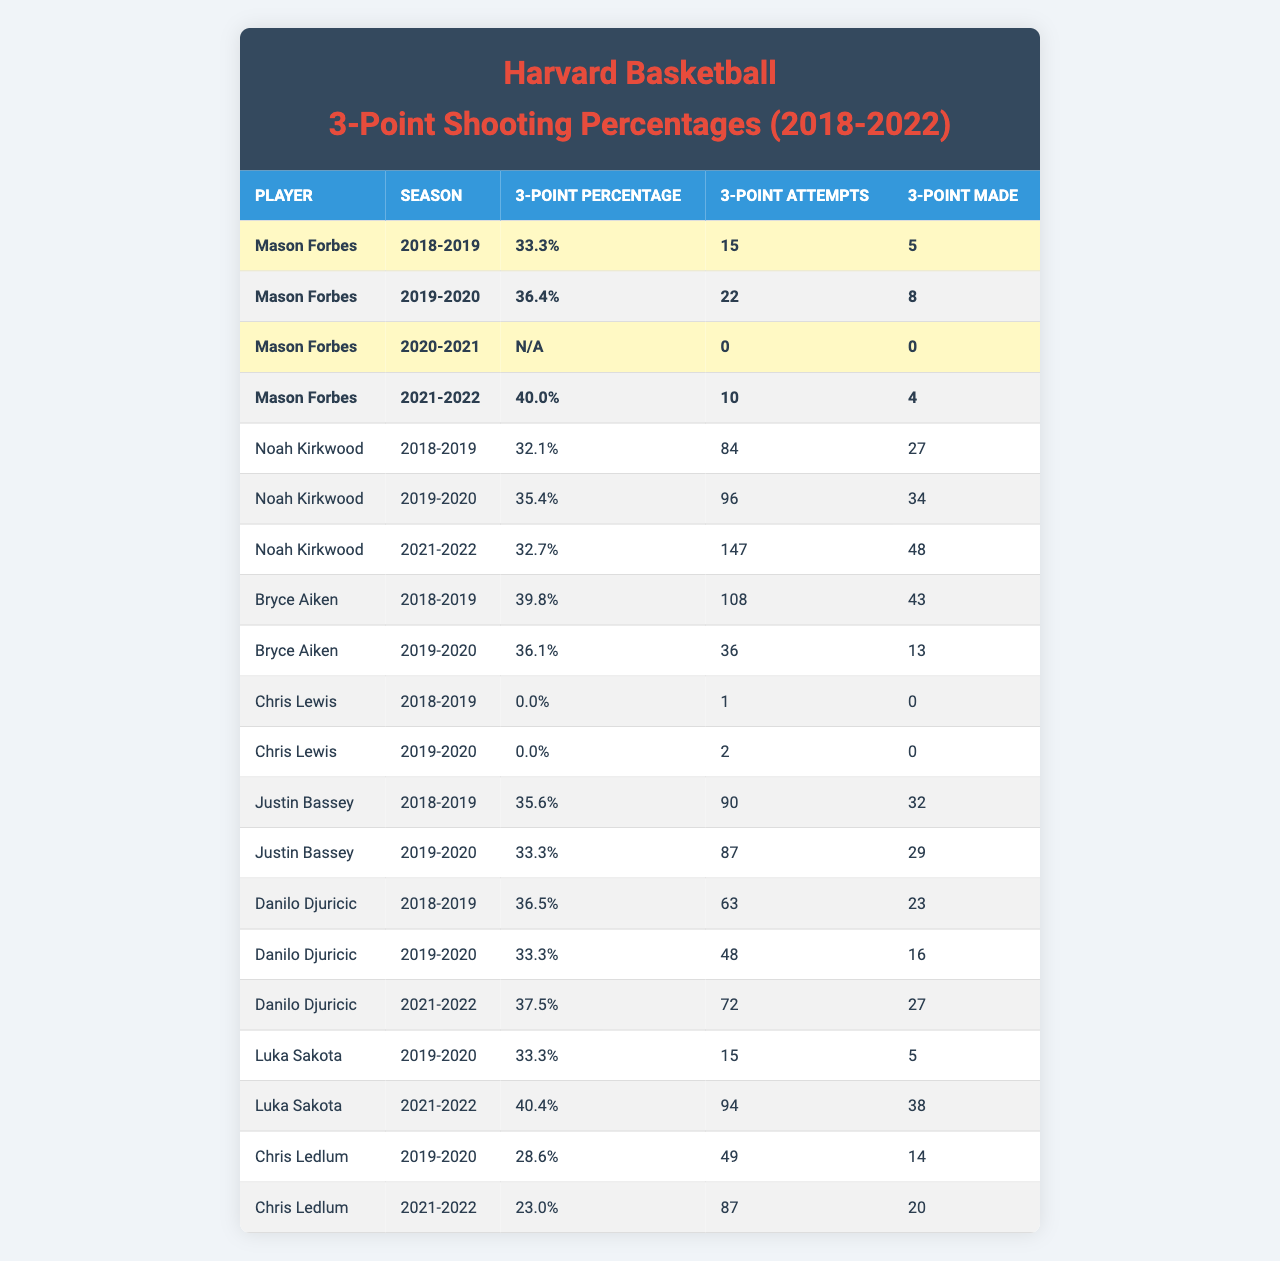What was Mason Forbes' highest 3-point shooting percentage during the 2018-2022 seasons? The highest percentage listed for Mason Forbes is 40.0%, which he achieved in the 2021-2022 season.
Answer: 40.0% How many 3-pointers did Noah Kirkwood make in the 2020-2021 season? Noah Kirkwood did not play during the 2020-2021 season, so he made 0 3-pointers.
Answer: 0 Which player had the most 3-point attempts in the 2019-2020 season? Noah Kirkwood had the most attempts with 96 in the 2019-2020 season.
Answer: Noah Kirkwood What is the 3-point shooting percentage of Bryce Aiken in the 2019-2020 season? Bryce Aiken's 3-point shooting percentage in the 2019-2020 season was 36.1%.
Answer: 36.1% Did Chris Lewis make any 3-pointers during his time at Harvard? Chris Lewis did not make any 3-pointers, as his stats show 0 made in both the 2018-2019 and 2019-2020 seasons.
Answer: Yes What is the average 3-point shooting percentage for Danilo Djuricic across the seasons he played? To find the average, sum his percentages: (36.5% + 33.3% + 37.5%) = 107.3%. Then divide by 3 seasons, giving an average of about 35.8%.
Answer: 35.8% How many total 3-pointers did Luka Sakota make in the 2021-2022 season? Luka Sakota made 38 3-pointers in the 2021-2022 season, as indicated by the data.
Answer: 38 What is the difference in 3-point shooting percentage between Justin Bassey in 2018-2019 and Mason Forbes in 2021-2022? Justin Bassey had a percentage of 35.6% in 2018-2019, while Mason Forbes had 40.0% in 2021-2022. The difference is 40.0% - 35.6% = 4.4%.
Answer: 4.4% Which player recorded the highest number of 3-point attempts in the 2018-2019 season? Bryce Aiken had the highest number of attempts with 108 in the 2018-2019 season.
Answer: Bryce Aiken Was Mason Forbes more consistent in his 3-point shooting across all seasons compared to Noah Kirkwood? To determine consistency, compare the variation in their percentages: Mason Forbes had 33.3%, 36.4%, N/A, and 40.0%. Noah Kirkwood had 32.1%, 35.4%, N/A, and 32.7%. Mason's range is 6.7% while Noah's is 3.3%; thus, Mason showed more variation and less consistency.
Answer: No 